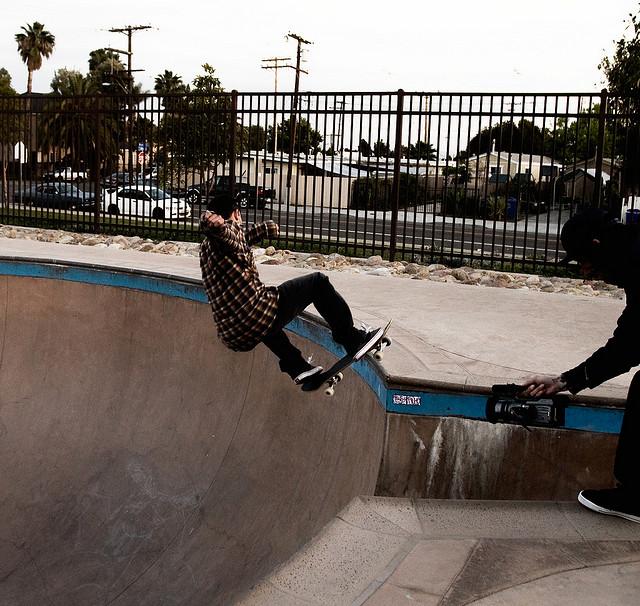Is the guy planning to jump over the fence?
Short answer required. No. Is the performer on the ground?
Give a very brief answer. No. How good is this guy in skating?
Answer briefly. Good. 